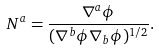Convert formula to latex. <formula><loc_0><loc_0><loc_500><loc_500>N ^ { a } = \frac { \nabla ^ { a } \phi } { ( \nabla ^ { b } \phi \nabla _ { b } \phi ) ^ { 1 / 2 } } .</formula> 